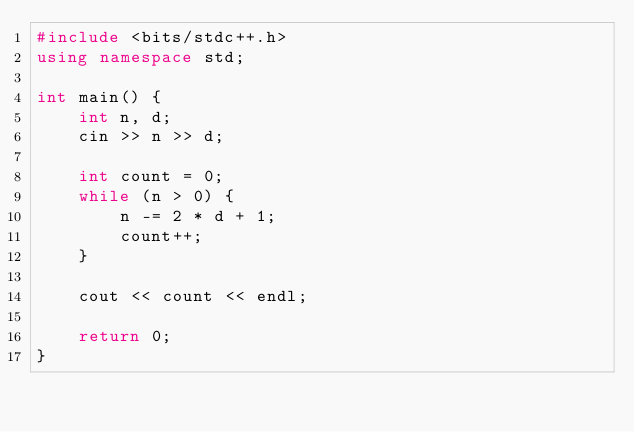<code> <loc_0><loc_0><loc_500><loc_500><_C++_>#include <bits/stdc++.h>
using namespace std;

int main() {
    int n, d;
    cin >> n >> d;

    int count = 0;
    while (n > 0) {
        n -= 2 * d + 1;
        count++;
    }

    cout << count << endl;

    return 0;
}</code> 